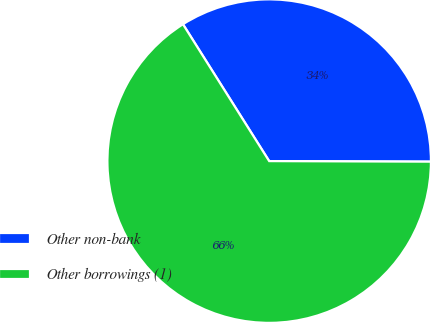Convert chart. <chart><loc_0><loc_0><loc_500><loc_500><pie_chart><fcel>Other non-bank<fcel>Other borrowings (1)<nl><fcel>34.0%<fcel>66.0%<nl></chart> 